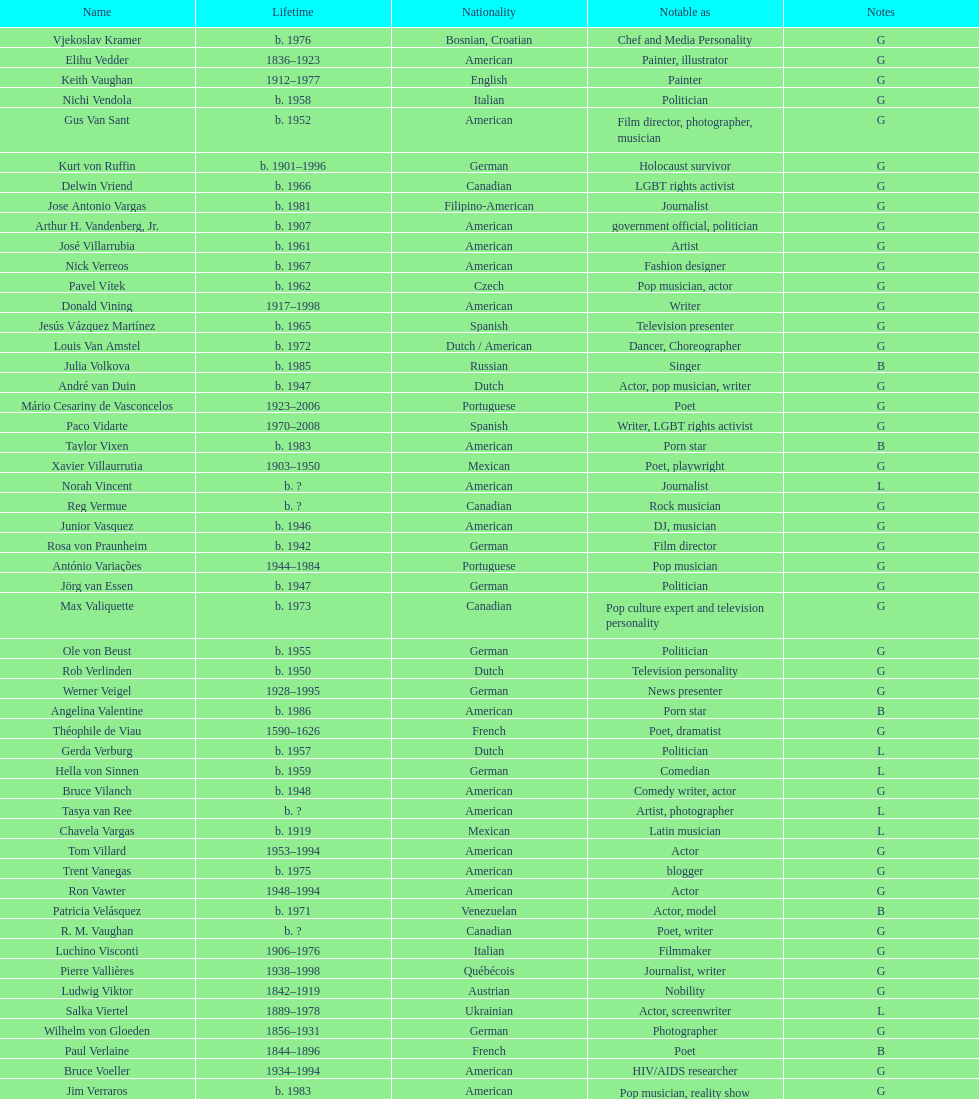Would you be able to parse every entry in this table? {'header': ['Name', 'Lifetime', 'Nationality', 'Notable as', 'Notes'], 'rows': [['Vjekoslav Kramer', 'b. 1976', 'Bosnian, Croatian', 'Chef and Media Personality', 'G'], ['Elihu Vedder', '1836–1923', 'American', 'Painter, illustrator', 'G'], ['Keith Vaughan', '1912–1977', 'English', 'Painter', 'G'], ['Nichi Vendola', 'b. 1958', 'Italian', 'Politician', 'G'], ['Gus Van Sant', 'b. 1952', 'American', 'Film director, photographer, musician', 'G'], ['Kurt von Ruffin', 'b. 1901–1996', 'German', 'Holocaust survivor', 'G'], ['Delwin Vriend', 'b. 1966', 'Canadian', 'LGBT rights activist', 'G'], ['Jose Antonio Vargas', 'b. 1981', 'Filipino-American', 'Journalist', 'G'], ['Arthur H. Vandenberg, Jr.', 'b. 1907', 'American', 'government official, politician', 'G'], ['José Villarrubia', 'b. 1961', 'American', 'Artist', 'G'], ['Nick Verreos', 'b. 1967', 'American', 'Fashion designer', 'G'], ['Pavel Vítek', 'b. 1962', 'Czech', 'Pop musician, actor', 'G'], ['Donald Vining', '1917–1998', 'American', 'Writer', 'G'], ['Jesús Vázquez Martínez', 'b. 1965', 'Spanish', 'Television presenter', 'G'], ['Louis Van Amstel', 'b. 1972', 'Dutch / American', 'Dancer, Choreographer', 'G'], ['Julia Volkova', 'b. 1985', 'Russian', 'Singer', 'B'], ['André van Duin', 'b. 1947', 'Dutch', 'Actor, pop musician, writer', 'G'], ['Mário Cesariny de Vasconcelos', '1923–2006', 'Portuguese', 'Poet', 'G'], ['Paco Vidarte', '1970–2008', 'Spanish', 'Writer, LGBT rights activist', 'G'], ['Taylor Vixen', 'b. 1983', 'American', 'Porn star', 'B'], ['Xavier Villaurrutia', '1903–1950', 'Mexican', 'Poet, playwright', 'G'], ['Norah Vincent', 'b.\xa0?', 'American', 'Journalist', 'L'], ['Reg Vermue', 'b.\xa0?', 'Canadian', 'Rock musician', 'G'], ['Junior Vasquez', 'b. 1946', 'American', 'DJ, musician', 'G'], ['Rosa von Praunheim', 'b. 1942', 'German', 'Film director', 'G'], ['António Variações', '1944–1984', 'Portuguese', 'Pop musician', 'G'], ['Jörg van Essen', 'b. 1947', 'German', 'Politician', 'G'], ['Max Valiquette', 'b. 1973', 'Canadian', 'Pop culture expert and television personality', 'G'], ['Ole von Beust', 'b. 1955', 'German', 'Politician', 'G'], ['Rob Verlinden', 'b. 1950', 'Dutch', 'Television personality', 'G'], ['Werner Veigel', '1928–1995', 'German', 'News presenter', 'G'], ['Angelina Valentine', 'b. 1986', 'American', 'Porn star', 'B'], ['Théophile de Viau', '1590–1626', 'French', 'Poet, dramatist', 'G'], ['Gerda Verburg', 'b. 1957', 'Dutch', 'Politician', 'L'], ['Hella von Sinnen', 'b. 1959', 'German', 'Comedian', 'L'], ['Bruce Vilanch', 'b. 1948', 'American', 'Comedy writer, actor', 'G'], ['Tasya van Ree', 'b.\xa0?', 'American', 'Artist, photographer', 'L'], ['Chavela Vargas', 'b. 1919', 'Mexican', 'Latin musician', 'L'], ['Tom Villard', '1953–1994', 'American', 'Actor', 'G'], ['Trent Vanegas', 'b. 1975', 'American', 'blogger', 'G'], ['Ron Vawter', '1948–1994', 'American', 'Actor', 'G'], ['Patricia Velásquez', 'b. 1971', 'Venezuelan', 'Actor, model', 'B'], ['R. M. Vaughan', 'b.\xa0?', 'Canadian', 'Poet, writer', 'G'], ['Luchino Visconti', '1906–1976', 'Italian', 'Filmmaker', 'G'], ['Pierre Vallières', '1938–1998', 'Québécois', 'Journalist, writer', 'G'], ['Ludwig Viktor', '1842–1919', 'Austrian', 'Nobility', 'G'], ['Salka Viertel', '1889–1978', 'Ukrainian', 'Actor, screenwriter', 'L'], ['Wilhelm von Gloeden', '1856–1931', 'German', 'Photographer', 'G'], ['Paul Verlaine', '1844–1896', 'French', 'Poet', 'B'], ['Bruce Voeller', '1934–1994', 'American', 'HIV/AIDS researcher', 'G'], ['Jim Verraros', 'b. 1983', 'American', 'Pop musician, reality show contestant', 'G'], ['Börje Vestlund', 'b. 1960', 'Swedish', 'Politician', 'G'], ["Alain-Philippe Malagnac d'Argens de Villèle", '1950–2000', 'French', 'Aristocrat', 'G'], ['Jennifer Veiga', 'b. 1962', 'American', 'Politician', 'L'], ['Carmen Vázquez', 'b.\xa0?', 'Cuban-American', 'Activist, writer', 'L'], ['Daniel Vosovic', 'b. 1981', 'American', 'Fashion designer', 'G'], ['John Vassall', '1924–1996', 'English', 'Civil servant, spy', 'G'], ['Lupe Valdez', 'b. 1947', 'American', 'Sheriff', 'L'], ['Christine Vachon', 'b. 1962', 'American', 'Film producer', 'L'], ['Tim Van Zandt', 'b. 1963', 'American', 'Politician, nurse, accountant', 'G'], ['Carl Van Vechten', '1880–1964', 'American', 'Writer, photographer', 'G'], ['Gianni Vattimo', 'b. 1936', 'Italian', 'Writer, philosopher', 'G'], ['Gore Vidal', '1925–2012', 'American', 'Writer, actor', 'B'], ['Jörg van Essen', 'b. 1947', 'German', 'Prosecutor and politician', 'G'], ['Maurice Vellekoop', 'b. 1964', 'Canadian', 'Illustrator and comics artist.', 'G'], ['Renée Vivien', '1877–1909', 'English', 'Poet', 'L'], ['Claude Vivier', '1948–1983', 'Canadian', '20th century classical composer', 'G'], ['Paula Vogel', 'b. 1951', 'American', 'Playwright', 'L'], ['Lena Videkull', 'b. 1962', 'Swedish', 'Footballer', 'L'], ['Ruth Vanita', 'b. 1955', 'Indian', 'Academic, activist', 'L'], ['Gianni Versace', '1946–1997', 'Italian', 'Fashion designer', 'G'], ['Anthony Venn-Brown', 'b. 1951', 'Australian', 'Author, former evangelist', 'G'], ['Urvashi Vaid', 'b. 1958', 'Indian-American', 'LGBT rights activist, lawyer', 'L']]} Which nationality has the most people associated with it? American. 